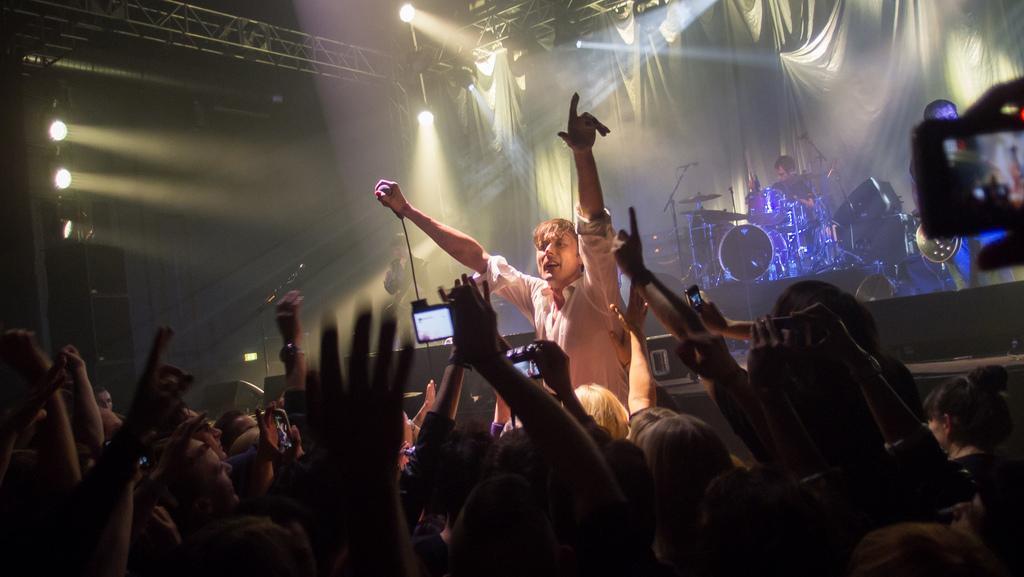Can you describe this image briefly? In this image, we can see a crowd. There is a person playing a musical instruments on the right side of the image. There are lights on the left and at the top of the image. There is a metal frame in the top left of the image. There is a screen on the right side of the image. 